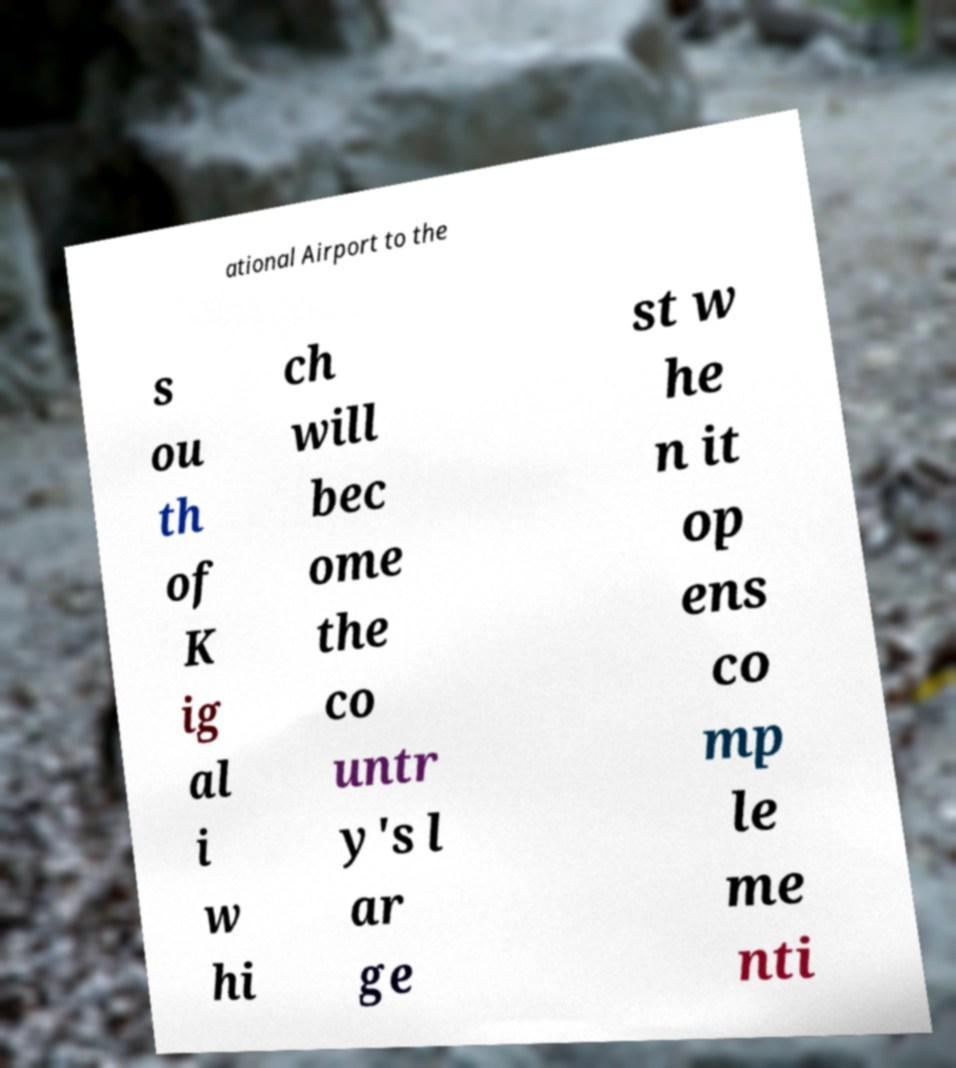Could you assist in decoding the text presented in this image and type it out clearly? ational Airport to the s ou th of K ig al i w hi ch will bec ome the co untr y's l ar ge st w he n it op ens co mp le me nti 